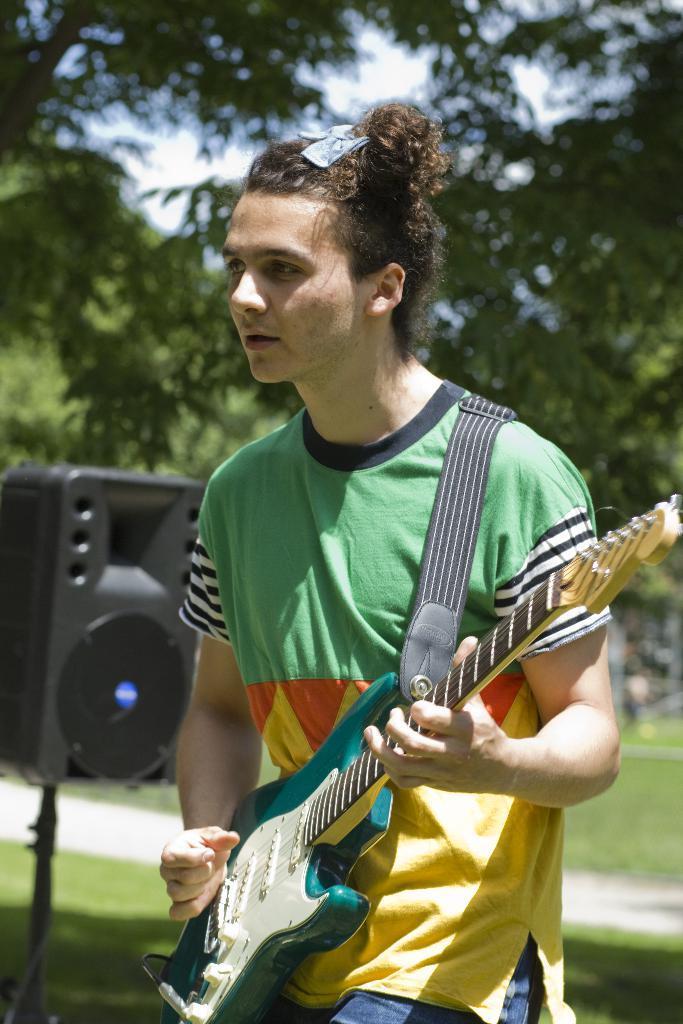Could you give a brief overview of what you see in this image? In this picture we can see a man who is playing guitar. This is grass. On the background we can see some trees and this is sky. 